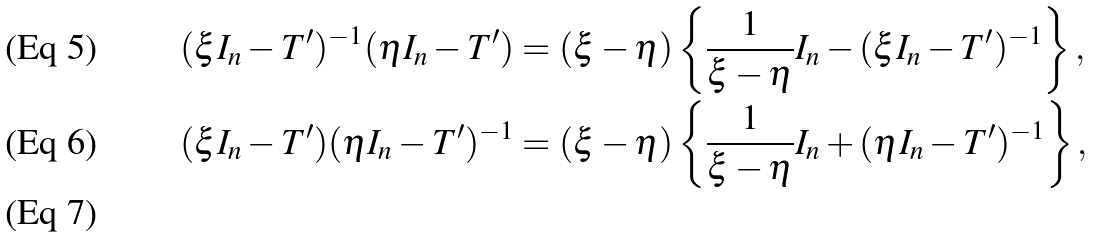<formula> <loc_0><loc_0><loc_500><loc_500>( \xi I _ { n } - T ^ { \prime } ) ^ { - 1 } ( \eta I _ { n } - T ^ { \prime } ) & = ( \xi - \eta ) \left \{ \frac { 1 } { \xi - \eta } I _ { n } - ( \xi I _ { n } - T ^ { \prime } ) ^ { - 1 } \right \} , \\ ( \xi I _ { n } - T ^ { \prime } ) ( \eta I _ { n } - T ^ { \prime } ) ^ { - 1 } & = ( \xi - \eta ) \left \{ \frac { 1 } { \xi - \eta } I _ { n } + ( \eta I _ { n } - T ^ { \prime } ) ^ { - 1 } \right \} , \\</formula> 